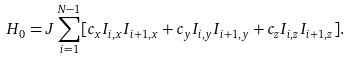<formula> <loc_0><loc_0><loc_500><loc_500>H _ { 0 } = J \sum _ { i = 1 } ^ { N - 1 } [ c _ { x } { I } _ { i , x } { I } _ { i + 1 , x } + c _ { y } { I } _ { i , y } { I } _ { i + 1 , y } + c _ { z } { I } _ { i , z } { I } _ { i + 1 , z } ] .</formula> 